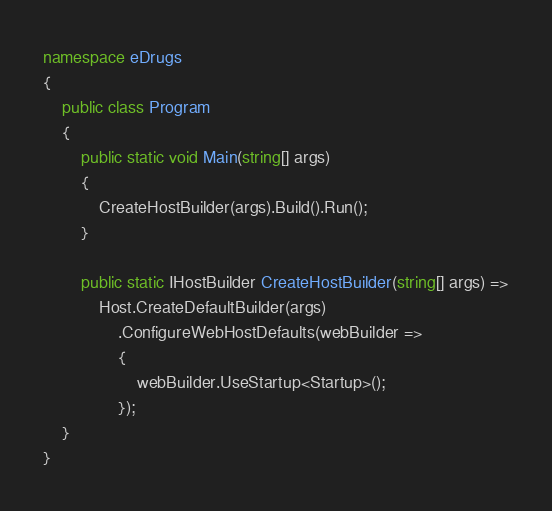<code> <loc_0><loc_0><loc_500><loc_500><_C#_>namespace eDrugs
{
    public class Program
    {
        public static void Main(string[] args)
        {
            CreateHostBuilder(args).Build().Run();
        }

        public static IHostBuilder CreateHostBuilder(string[] args) =>
            Host.CreateDefaultBuilder(args)
                .ConfigureWebHostDefaults(webBuilder =>
                {
                    webBuilder.UseStartup<Startup>();
                });
    }
}
</code> 